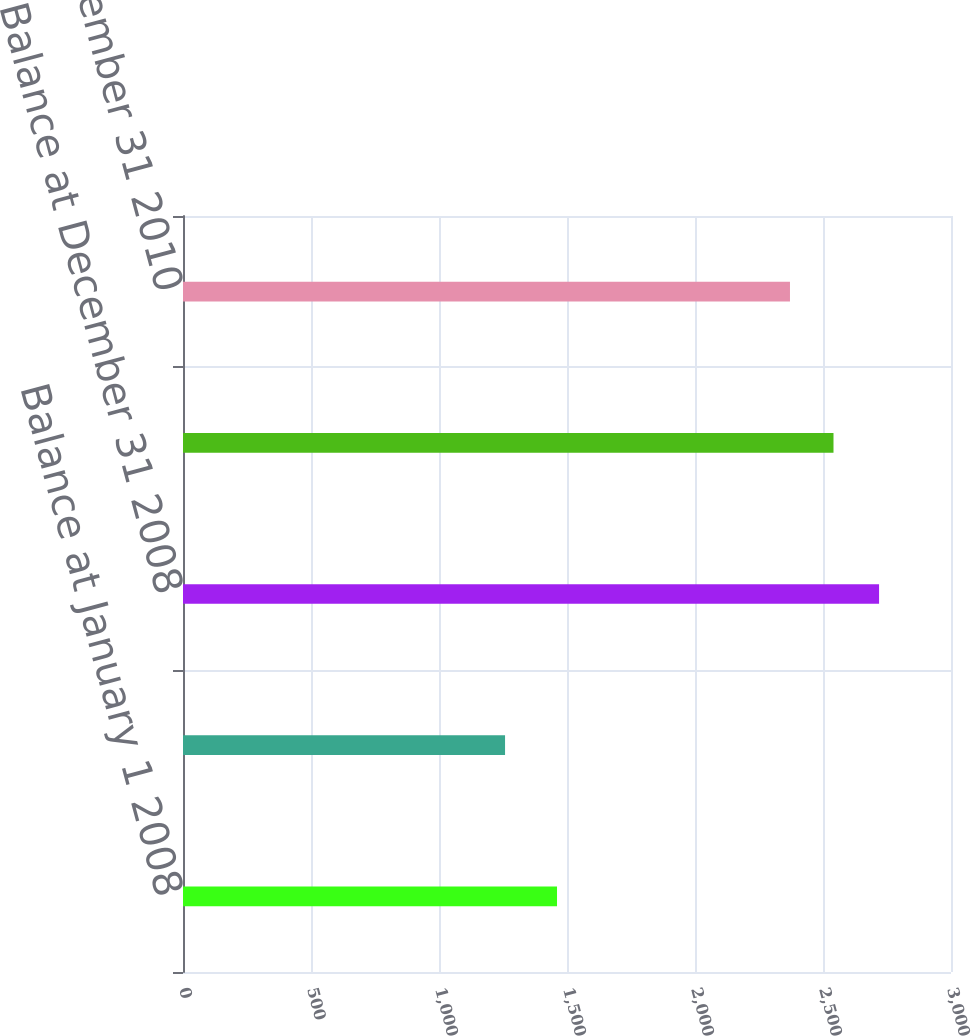Convert chart. <chart><loc_0><loc_0><loc_500><loc_500><bar_chart><fcel>Balance at January 1 2008<fcel>Other comprehensive<fcel>Balance at December 31 2008<fcel>Balance at December 31 2009<fcel>Balance at December 31 2010<nl><fcel>1461<fcel>1258<fcel>2719<fcel>2541<fcel>2371<nl></chart> 